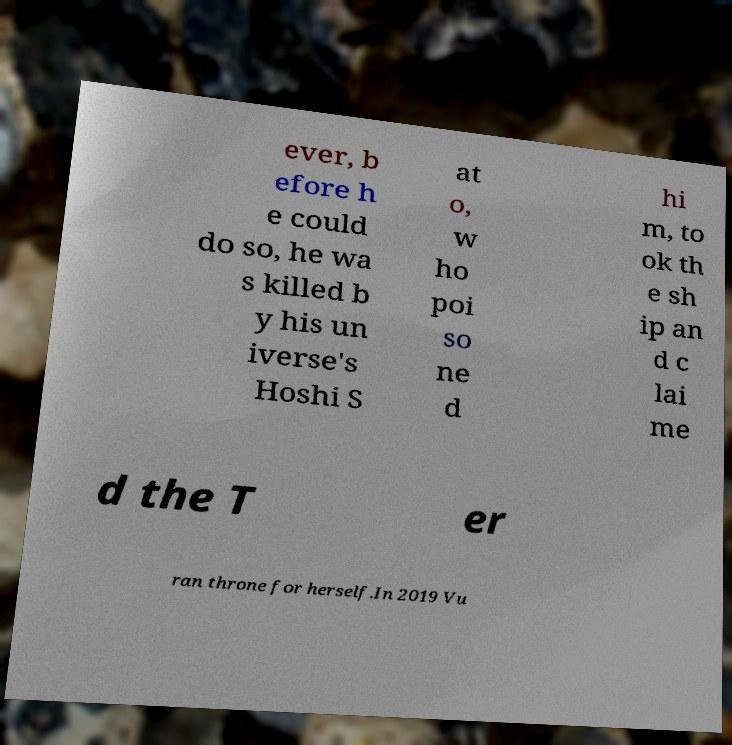I need the written content from this picture converted into text. Can you do that? ever, b efore h e could do so, he wa s killed b y his un iverse's Hoshi S at o, w ho poi so ne d hi m, to ok th e sh ip an d c lai me d the T er ran throne for herself.In 2019 Vu 